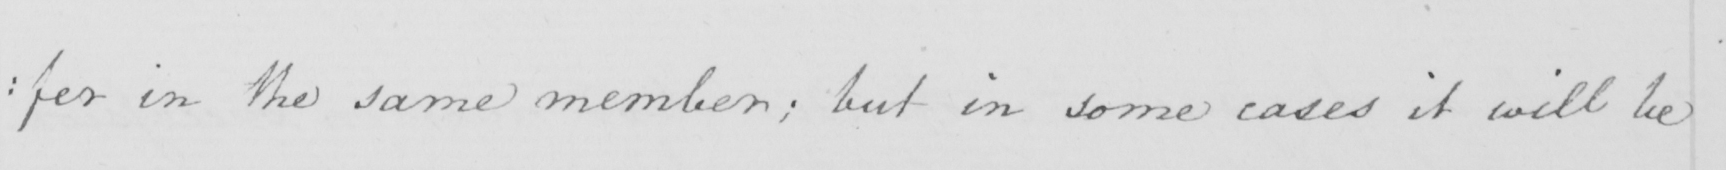Can you tell me what this handwritten text says? : fer in the same member ; but in some cases it will be 